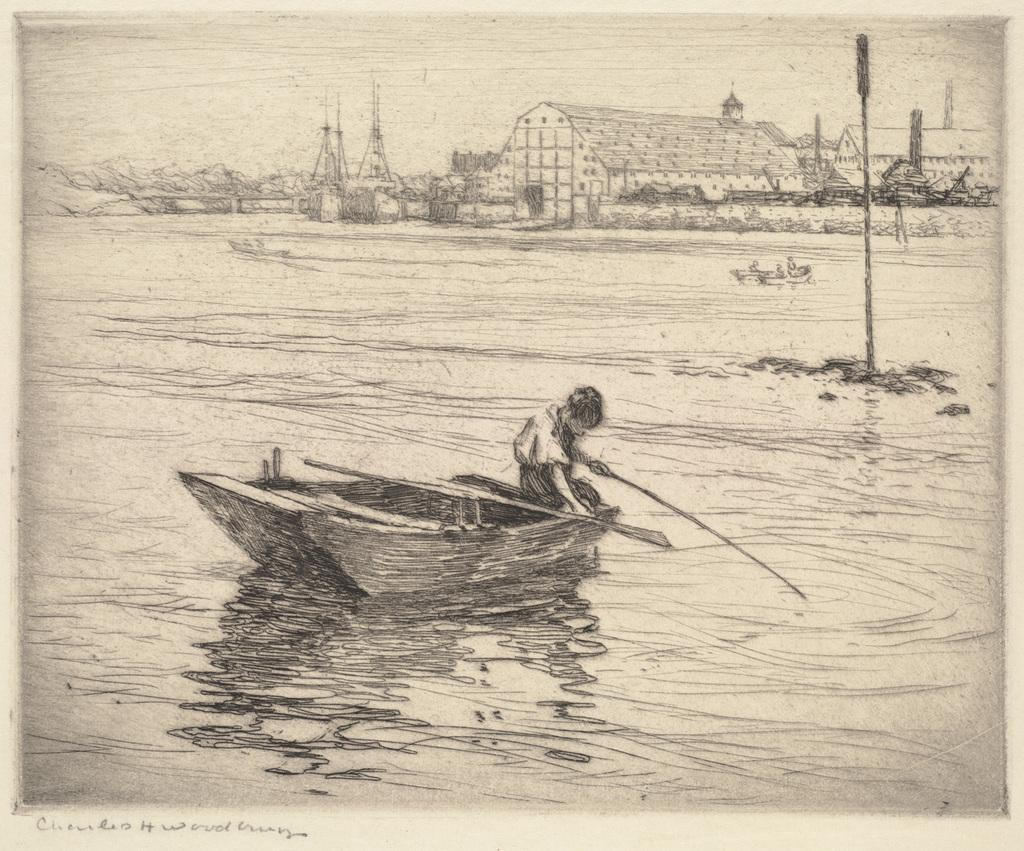What is depicted in the foreground of the poster? There is a sketch of a person on a boat in the foreground of the poster. What can be seen in the background of the poster? There are buildings, towers, water, and the sky visible in the background of the poster. How many tomatoes are hanging from the towers in the background of the poster? There are no tomatoes present in the image, and therefore no tomatoes can be seen hanging from the towers. What type of amusement park can be seen in the background of the poster? There is no amusement park depicted in the image; it features a sketch of a person on a boat in the foreground and buildings, towers, water, and the sky in the background. 